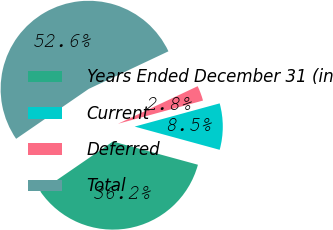<chart> <loc_0><loc_0><loc_500><loc_500><pie_chart><fcel>Years Ended December 31 (in<fcel>Current<fcel>Deferred<fcel>Total<nl><fcel>36.17%<fcel>8.49%<fcel>2.77%<fcel>52.57%<nl></chart> 